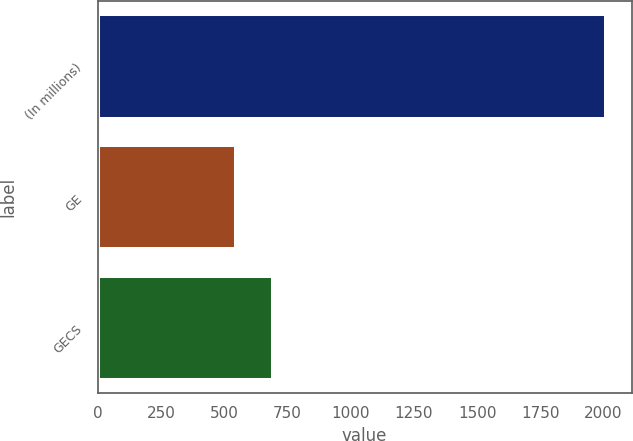Convert chart to OTSL. <chart><loc_0><loc_0><loc_500><loc_500><bar_chart><fcel>(In millions)<fcel>GE<fcel>GECS<nl><fcel>2010<fcel>548<fcel>694.2<nl></chart> 